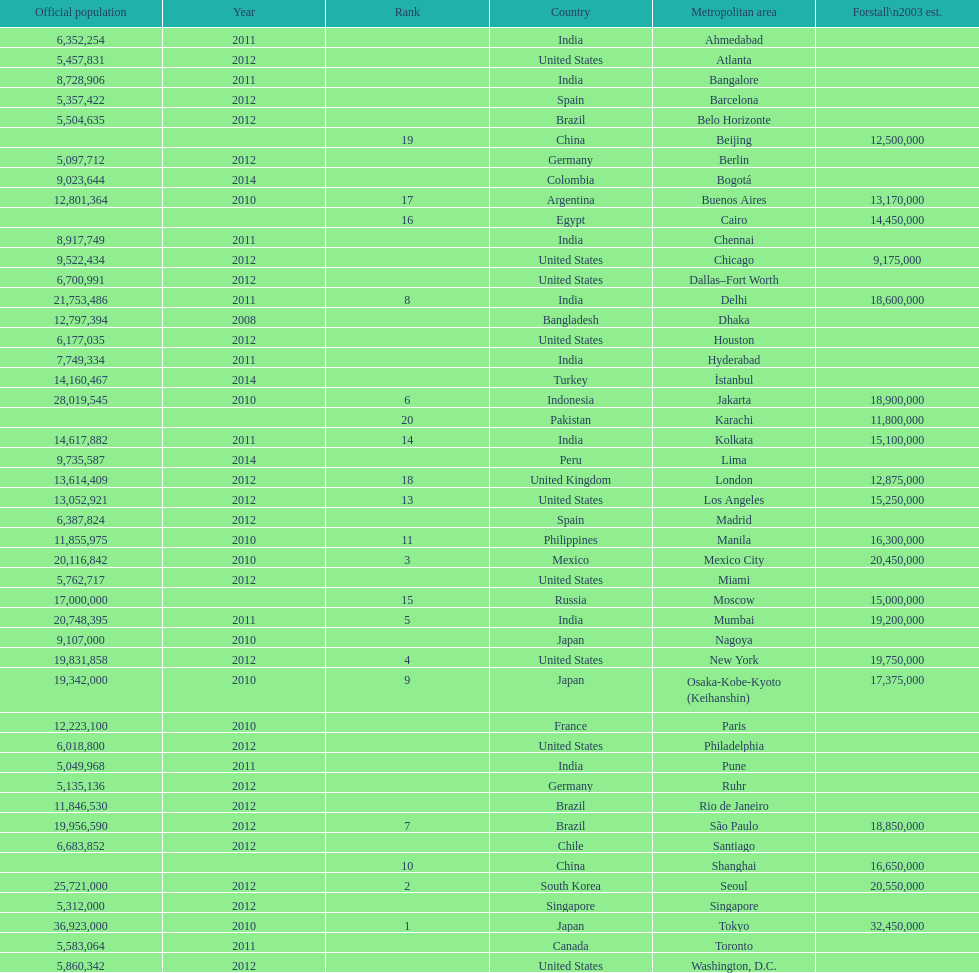How many cities are in the united states? 9. 